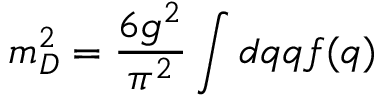<formula> <loc_0><loc_0><loc_500><loc_500>m _ { D } ^ { 2 } = \frac { 6 g ^ { 2 } } { \pi ^ { 2 } } \int d q q f ( q )</formula> 